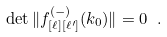Convert formula to latex. <formula><loc_0><loc_0><loc_500><loc_500>\det \| f _ { [ \ell ] [ \ell ^ { \prime } ] } ^ { ( - ) } ( k _ { 0 } ) \| = 0 \ .</formula> 